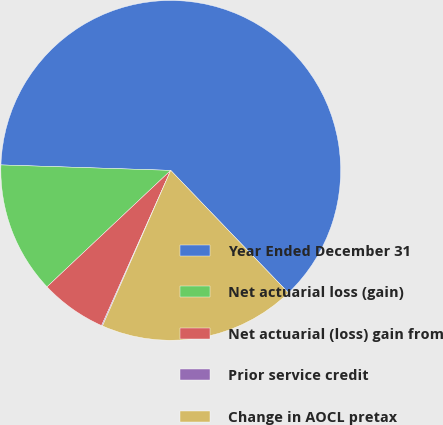Convert chart to OTSL. <chart><loc_0><loc_0><loc_500><loc_500><pie_chart><fcel>Year Ended December 31<fcel>Net actuarial loss (gain)<fcel>Net actuarial (loss) gain from<fcel>Prior service credit<fcel>Change in AOCL pretax<nl><fcel>62.3%<fcel>12.53%<fcel>6.31%<fcel>0.09%<fcel>18.76%<nl></chart> 